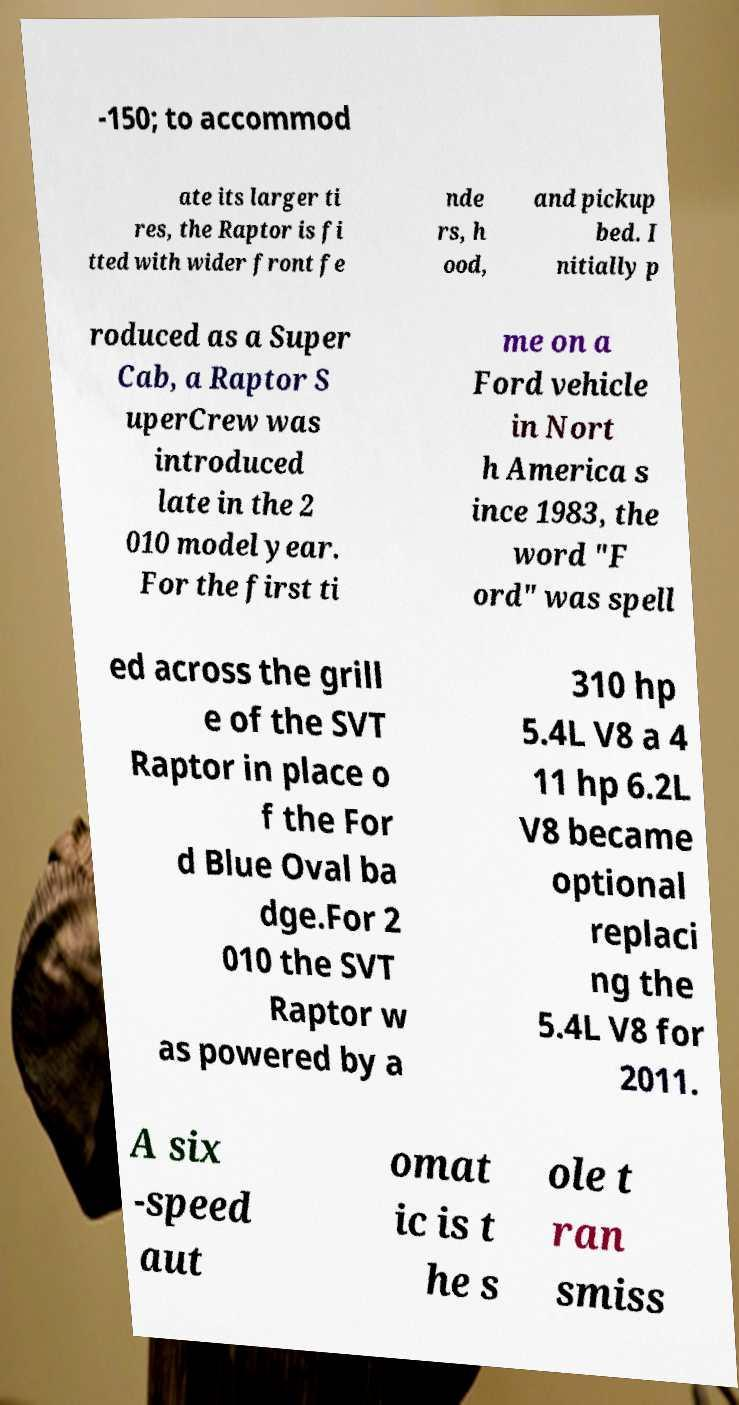Could you assist in decoding the text presented in this image and type it out clearly? -150; to accommod ate its larger ti res, the Raptor is fi tted with wider front fe nde rs, h ood, and pickup bed. I nitially p roduced as a Super Cab, a Raptor S uperCrew was introduced late in the 2 010 model year. For the first ti me on a Ford vehicle in Nort h America s ince 1983, the word "F ord" was spell ed across the grill e of the SVT Raptor in place o f the For d Blue Oval ba dge.For 2 010 the SVT Raptor w as powered by a 310 hp 5.4L V8 a 4 11 hp 6.2L V8 became optional replaci ng the 5.4L V8 for 2011. A six -speed aut omat ic is t he s ole t ran smiss 